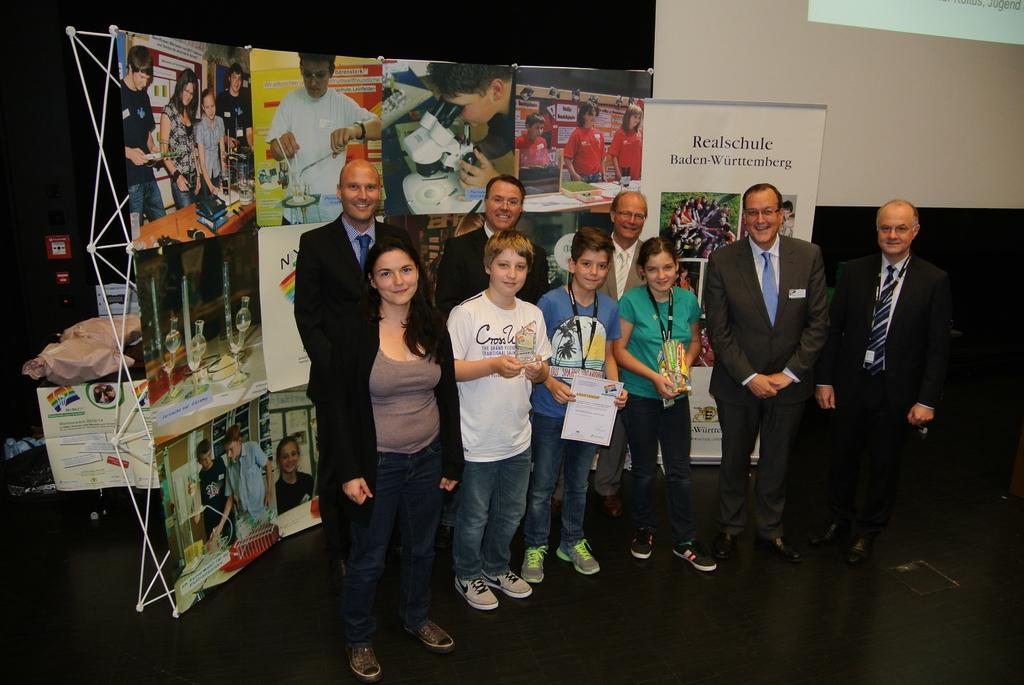How would you summarize this image in a sentence or two? In this image I can see few persons standing. I can see few banners with some text and images on it. 